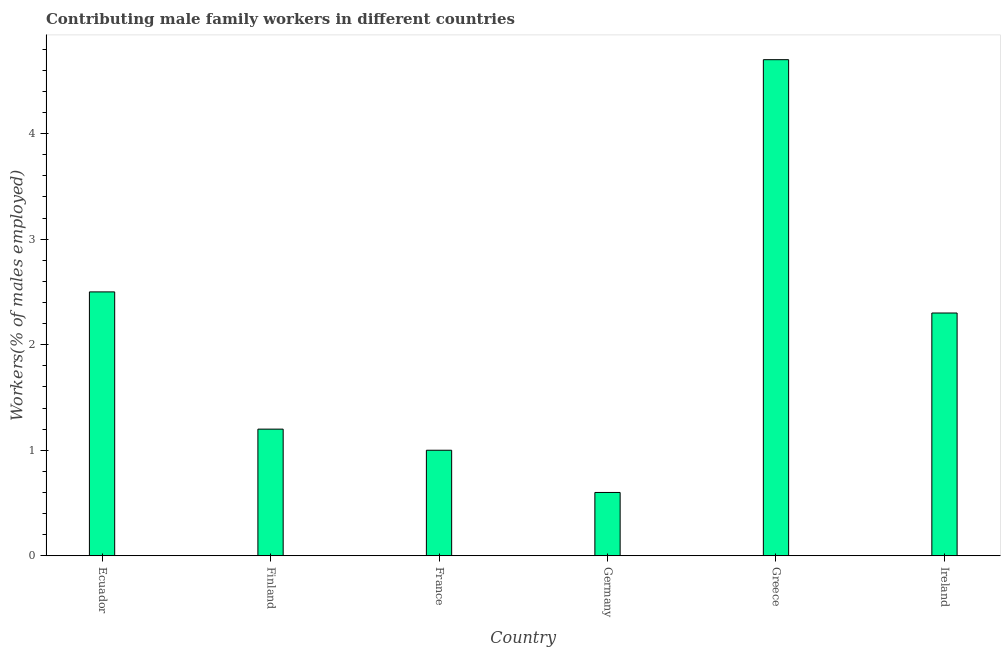What is the title of the graph?
Make the answer very short. Contributing male family workers in different countries. What is the label or title of the Y-axis?
Provide a succinct answer. Workers(% of males employed). What is the contributing male family workers in Finland?
Offer a very short reply. 1.2. Across all countries, what is the maximum contributing male family workers?
Offer a terse response. 4.7. Across all countries, what is the minimum contributing male family workers?
Make the answer very short. 0.6. In which country was the contributing male family workers minimum?
Offer a very short reply. Germany. What is the sum of the contributing male family workers?
Your answer should be very brief. 12.3. What is the average contributing male family workers per country?
Ensure brevity in your answer.  2.05. In how many countries, is the contributing male family workers greater than 3.6 %?
Your response must be concise. 1. What is the ratio of the contributing male family workers in Germany to that in Ireland?
Keep it short and to the point. 0.26. Is the difference between the contributing male family workers in France and Germany greater than the difference between any two countries?
Your answer should be compact. No. What is the difference between the highest and the second highest contributing male family workers?
Your response must be concise. 2.2. Is the sum of the contributing male family workers in Greece and Ireland greater than the maximum contributing male family workers across all countries?
Make the answer very short. Yes. What is the Workers(% of males employed) of Finland?
Ensure brevity in your answer.  1.2. What is the Workers(% of males employed) in France?
Provide a succinct answer. 1. What is the Workers(% of males employed) in Germany?
Provide a short and direct response. 0.6. What is the Workers(% of males employed) of Greece?
Provide a succinct answer. 4.7. What is the Workers(% of males employed) of Ireland?
Make the answer very short. 2.3. What is the difference between the Workers(% of males employed) in Ecuador and France?
Make the answer very short. 1.5. What is the difference between the Workers(% of males employed) in Ecuador and Greece?
Offer a very short reply. -2.2. What is the difference between the Workers(% of males employed) in Finland and Greece?
Offer a terse response. -3.5. What is the difference between the Workers(% of males employed) in France and Germany?
Offer a terse response. 0.4. What is the difference between the Workers(% of males employed) in France and Greece?
Your response must be concise. -3.7. What is the difference between the Workers(% of males employed) in Germany and Greece?
Provide a short and direct response. -4.1. What is the difference between the Workers(% of males employed) in Greece and Ireland?
Provide a short and direct response. 2.4. What is the ratio of the Workers(% of males employed) in Ecuador to that in Finland?
Your answer should be compact. 2.08. What is the ratio of the Workers(% of males employed) in Ecuador to that in France?
Offer a very short reply. 2.5. What is the ratio of the Workers(% of males employed) in Ecuador to that in Germany?
Keep it short and to the point. 4.17. What is the ratio of the Workers(% of males employed) in Ecuador to that in Greece?
Make the answer very short. 0.53. What is the ratio of the Workers(% of males employed) in Ecuador to that in Ireland?
Give a very brief answer. 1.09. What is the ratio of the Workers(% of males employed) in Finland to that in France?
Offer a terse response. 1.2. What is the ratio of the Workers(% of males employed) in Finland to that in Greece?
Offer a terse response. 0.26. What is the ratio of the Workers(% of males employed) in Finland to that in Ireland?
Ensure brevity in your answer.  0.52. What is the ratio of the Workers(% of males employed) in France to that in Germany?
Provide a short and direct response. 1.67. What is the ratio of the Workers(% of males employed) in France to that in Greece?
Provide a succinct answer. 0.21. What is the ratio of the Workers(% of males employed) in France to that in Ireland?
Make the answer very short. 0.43. What is the ratio of the Workers(% of males employed) in Germany to that in Greece?
Your response must be concise. 0.13. What is the ratio of the Workers(% of males employed) in Germany to that in Ireland?
Keep it short and to the point. 0.26. What is the ratio of the Workers(% of males employed) in Greece to that in Ireland?
Your answer should be compact. 2.04. 